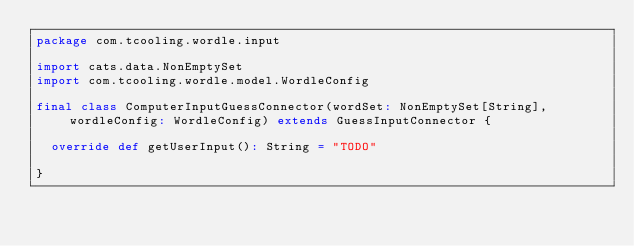<code> <loc_0><loc_0><loc_500><loc_500><_Scala_>package com.tcooling.wordle.input

import cats.data.NonEmptySet
import com.tcooling.wordle.model.WordleConfig

final class ComputerInputGuessConnector(wordSet: NonEmptySet[String], wordleConfig: WordleConfig) extends GuessInputConnector {

  override def getUserInput(): String = "TODO"

}
</code> 